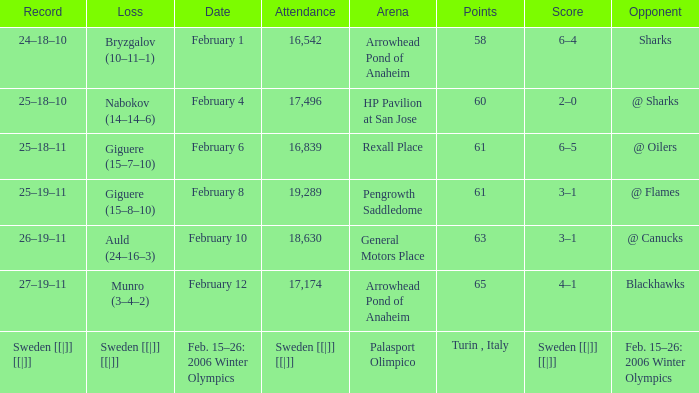Would you mind parsing the complete table? {'header': ['Record', 'Loss', 'Date', 'Attendance', 'Arena', 'Points', 'Score', 'Opponent'], 'rows': [['24–18–10', 'Bryzgalov (10–11–1)', 'February 1', '16,542', 'Arrowhead Pond of Anaheim', '58', '6–4', 'Sharks'], ['25–18–10', 'Nabokov (14–14–6)', 'February 4', '17,496', 'HP Pavilion at San Jose', '60', '2–0', '@ Sharks'], ['25–18–11', 'Giguere (15–7–10)', 'February 6', '16,839', 'Rexall Place', '61', '6–5', '@ Oilers'], ['25–19–11', 'Giguere (15–8–10)', 'February 8', '19,289', 'Pengrowth Saddledome', '61', '3–1', '@ Flames'], ['26–19–11', 'Auld (24–16–3)', 'February 10', '18,630', 'General Motors Place', '63', '3–1', '@ Canucks'], ['27–19–11', 'Munro (3–4–2)', 'February 12', '17,174', 'Arrowhead Pond of Anaheim', '65', '4–1', 'Blackhawks'], ['Sweden [[|]] [[|]]', 'Sweden [[|]] [[|]]', 'Feb. 15–26: 2006 Winter Olympics', 'Sweden [[|]] [[|]]', 'Palasport Olimpico', 'Turin , Italy', 'Sweden [[|]] [[|]]', 'Feb. 15–26: 2006 Winter Olympics']]} What is the points when the score was 3–1, and record was 25–19–11? 61.0. 